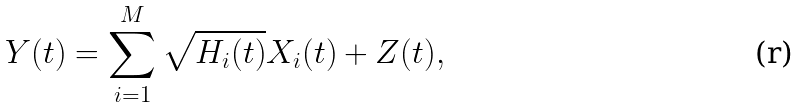<formula> <loc_0><loc_0><loc_500><loc_500>Y ( t ) = \sum _ { i = 1 } ^ { M } \sqrt { H _ { i } ( t ) } X _ { i } ( t ) + Z ( t ) ,</formula> 